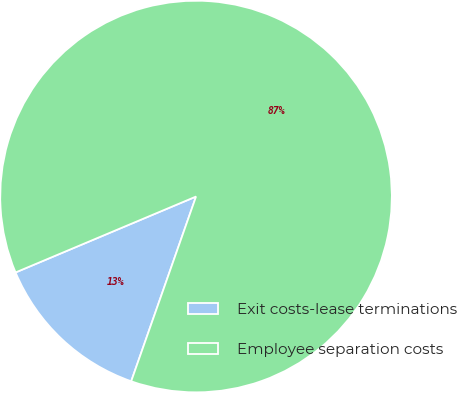<chart> <loc_0><loc_0><loc_500><loc_500><pie_chart><fcel>Exit costs-lease terminations<fcel>Employee separation costs<nl><fcel>13.29%<fcel>86.71%<nl></chart> 